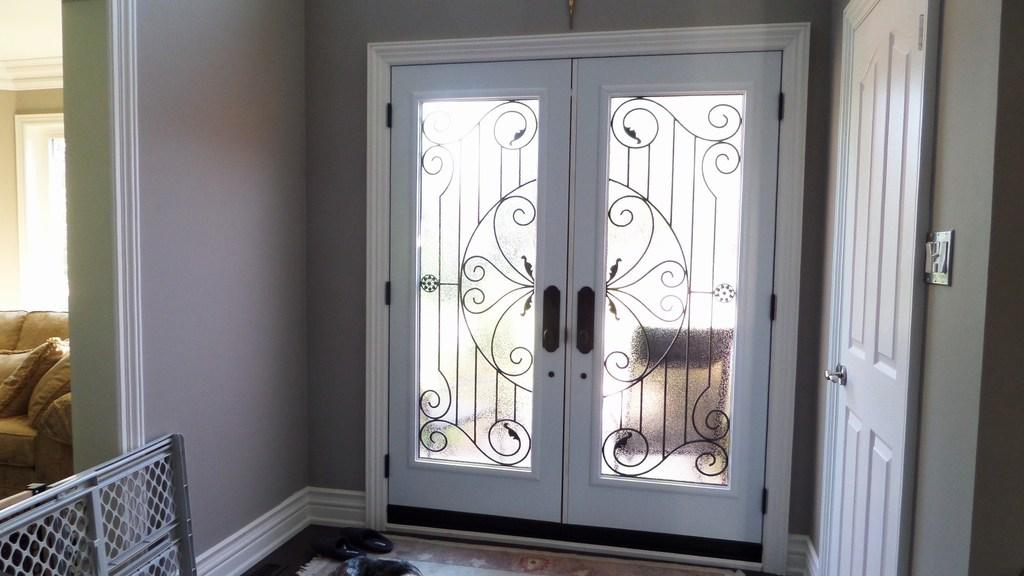What is located on the front of the wall in the image? There is a door in the front of the image on a wall. Are there any other doors visible in the image? Yes, there is another door on the right side of the image. Where was the image taken? The image was taken inside a room. What type of furniture can be seen on the left side of the image? There is a sofa visible on the left side of the image. How many moms are present in the image? There is no mention of a mom or any women in the image, so it is not possible to answer that question. What type of cannon is visible in the image? There is no cannon present in the image. 